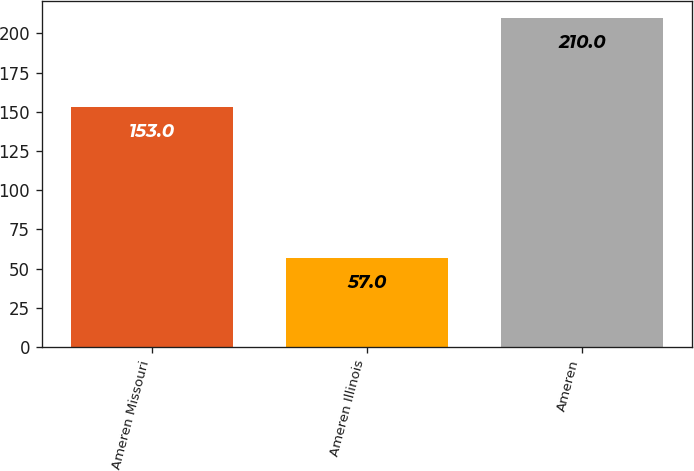<chart> <loc_0><loc_0><loc_500><loc_500><bar_chart><fcel>Ameren Missouri<fcel>Ameren Illinois<fcel>Ameren<nl><fcel>153<fcel>57<fcel>210<nl></chart> 